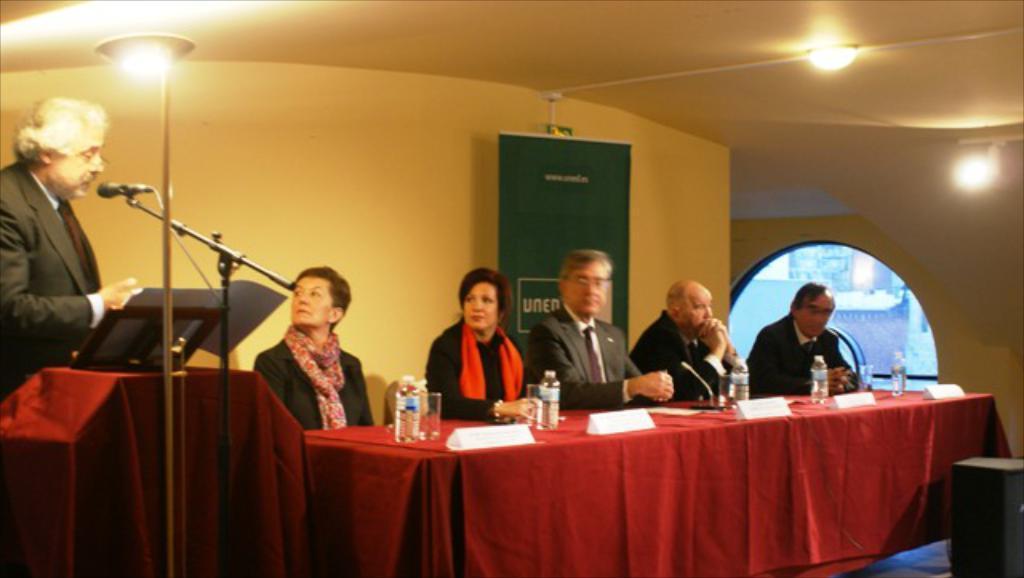Can you describe this image briefly? In the image we can see there are people sitting on the chair and on the table there are name plates and water bottles. There is a man standing near the podium and in front of him there is a mic with a stand. The women are wearing scarves and there are lights on the top. 